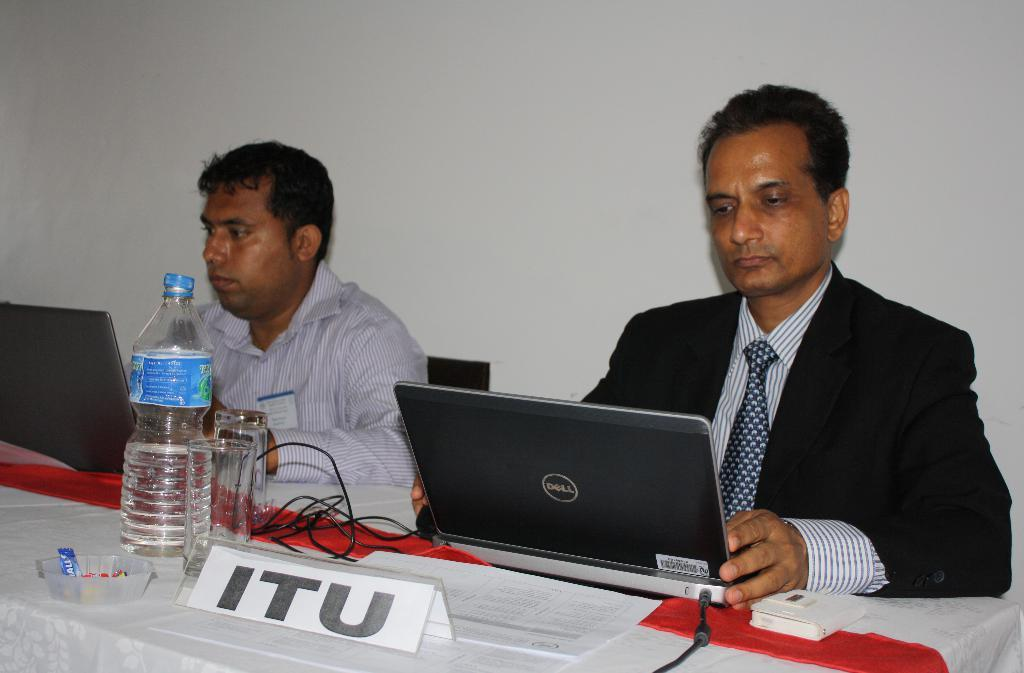<image>
Create a compact narrative representing the image presented. Representative of ITU on a laptop hard at work next to another person. 